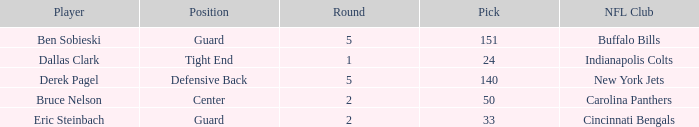Parse the full table. {'header': ['Player', 'Position', 'Round', 'Pick', 'NFL Club'], 'rows': [['Ben Sobieski', 'Guard', '5', '151', 'Buffalo Bills'], ['Dallas Clark', 'Tight End', '1', '24', 'Indianapolis Colts'], ['Derek Pagel', 'Defensive Back', '5', '140', 'New York Jets'], ['Bruce Nelson', 'Center', '2', '50', 'Carolina Panthers'], ['Eric Steinbach', 'Guard', '2', '33', 'Cincinnati Bengals']]} What was the latest round that Derek Pagel was selected with a pick higher than 50? 5.0. 